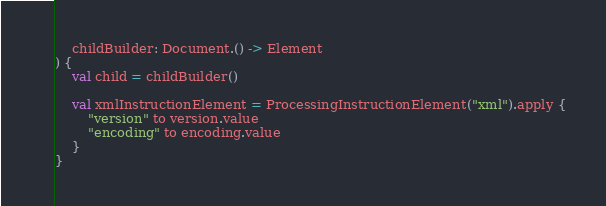Convert code to text. <code><loc_0><loc_0><loc_500><loc_500><_Kotlin_>    childBuilder: Document.() -> Element
) {
    val child = childBuilder()

    val xmlInstructionElement = ProcessingInstructionElement("xml").apply {
        "version" to version.value
        "encoding" to encoding.value
    }
}
</code> 